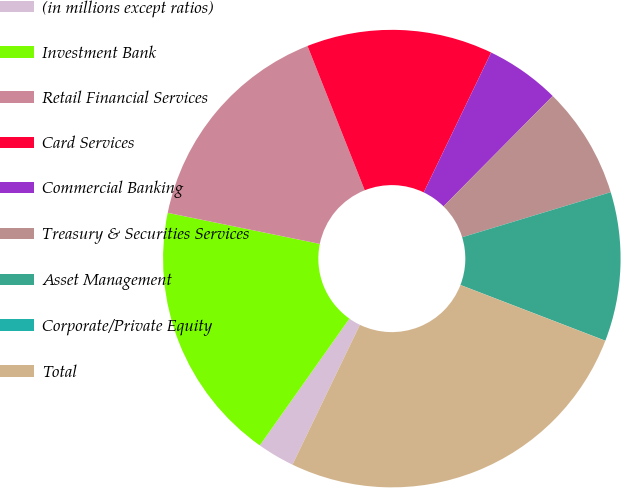Convert chart. <chart><loc_0><loc_0><loc_500><loc_500><pie_chart><fcel>(in millions except ratios)<fcel>Investment Bank<fcel>Retail Financial Services<fcel>Card Services<fcel>Commercial Banking<fcel>Treasury & Securities Services<fcel>Asset Management<fcel>Corporate/Private Equity<fcel>Total<nl><fcel>2.64%<fcel>18.42%<fcel>15.79%<fcel>13.16%<fcel>5.27%<fcel>7.9%<fcel>10.53%<fcel>0.01%<fcel>26.31%<nl></chart> 